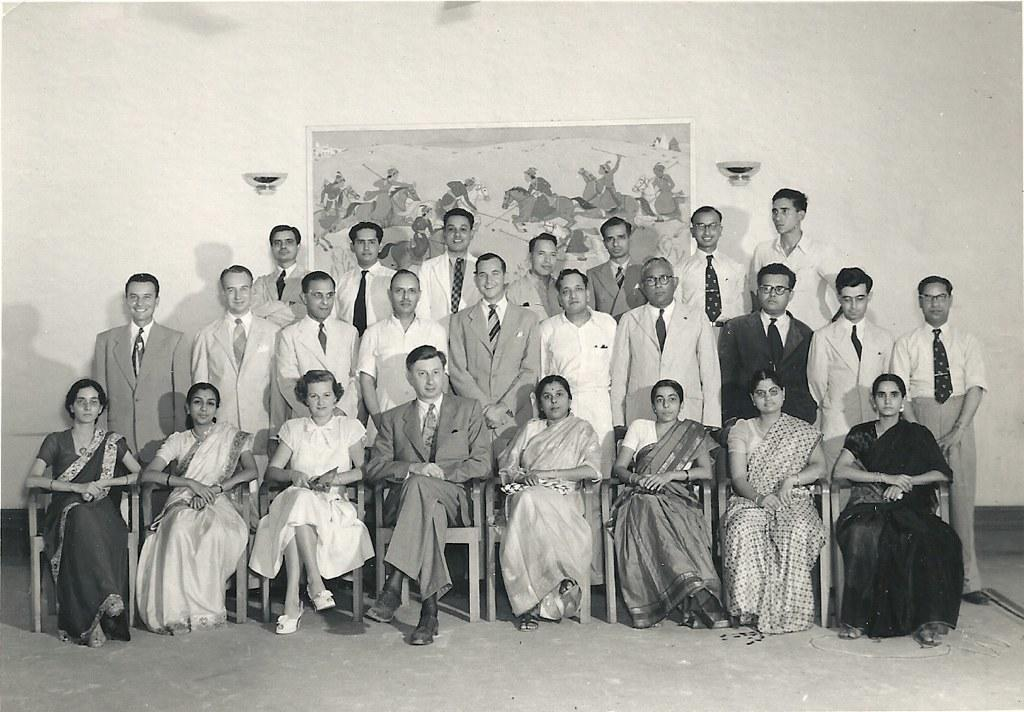How many people are in the image? There is a group of people in the image. What are the people in the image doing? Some people are seated, while others are standing. What can be seen in the background of the image? There is a poster on the wall in the background of the image. What type of pet can be seen playing with a tank in the image? There is no pet or tank present in the image; it features a group of people with some seated and others standing. 